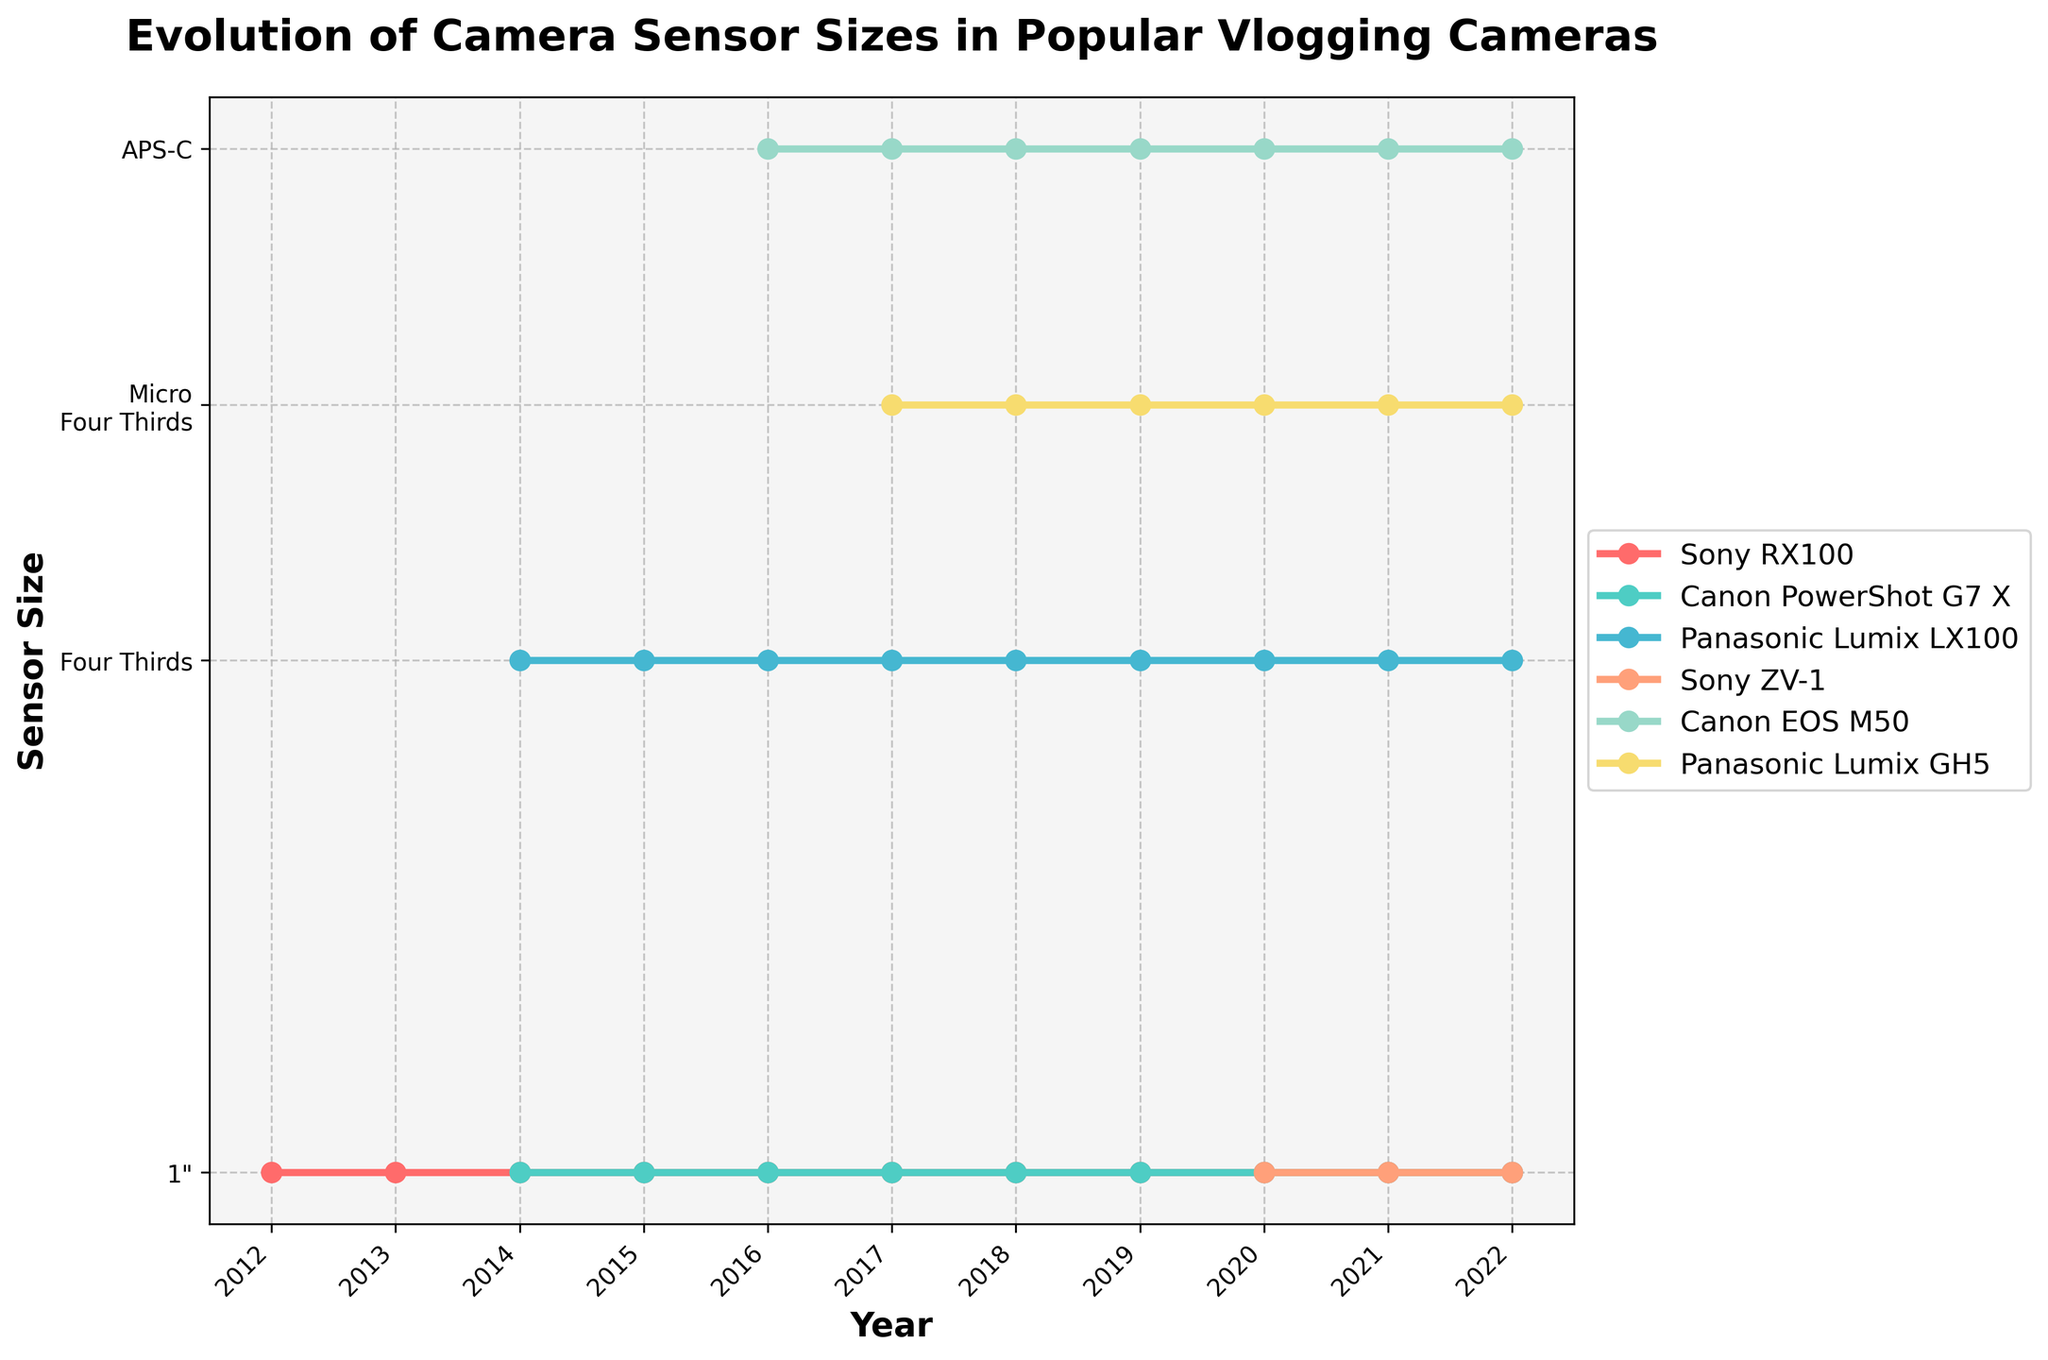Which camera introduced the '1"' sensor size first? By examining the plot, the earliest line labeled '1"' belongs to the Sony RX100 in 2012. Since this line starts from 2012, it's clear that the Sony RX100 was the first camera to introduce '1"' sensor size.
Answer: Sony RX100 In which year did the Panasonic Lumix GH5 first appear on the chart with a sensor size? By checking the plot for the first appearance of the Panasonic Lumix GH5 line, it is in 2017 when its line starts, indicating the sensor size was first noted that year.
Answer: 2017 How did the sensor size for Canon EOS M50 evolve from its introduction? The Canon EOS M50 line first appears in 2016 with a marker at APS-C, and it maintains this sensor size consistently through subsequent years up to 2022.
Answer: Stayed APS-C Compare the sensor sizes of Canon PowerShot G7 X and Panasonic Lumix LX100 in 2015. Which one has a larger sensor? According to the plot, in 2015, the Canon PowerShot G7 X has a sensor size of '1"', while the Panasonic Lumix LX100 has a 'Four Thirds' sensor size, where 'Four Thirds' is larger.
Answer: Panasonic Lumix LX100 Which camera brand has maintained the same sensor size throughout the decade? By observing the lines on the chart, the Sony RX100 has maintained a constant sensor size of '1"' from 2012 to 2022. Other cameras have had changes or were introduced later.
Answer: Sony RX100 In what year did the Sony ZV-1 first introduce, and what was its initial sensor size? By looking at the plot, the first appearance of the Sony ZV-1 line is in 2020 with a '1"' sensor size.
Answer: 2020, 1" On average, how many years does it take for a camera with '1"' sensor size to appear alongside new models? To find this, count the years when new camera models appeared with '1"' sensor sizes: Sony RX100 (2012), Canon PowerShot G7 X (2014), Sony ZV-1 (2020). Calculate the intervals, 2014-2012 = 2 years, 2020-2014 = 6 years, and find the average (2+6)/2 = 4 years.
Answer: 4 years Which camera models share the same sensor size in the year 2021? In 2021, the chart indicates that Sony RX100, Canon PowerShot G7 X, and Sony ZV-1 share the same sensor size of '1"'.
Answer: Sony RX100, Canon PowerShot G7 X, Sony ZV-1 What are the visual differences between the sensor sizes 'Four Thirds' and 'Micro Four Thirds'? Visually, 'Four Thirds' appears at a higher position on the vertical axis compared to 'Micro Four Thirds,' indicating it is larger. The chart uses different markers for these sizes and shows 'Four Thirds' closer to the APS-C line than 'Micro Four Thirds'.
Answer: 'Four Thirds' higher than 'Micro Four Thirds' What is the trend for Panasonic Lumix LX100 sensor size from its introduction year until 2022? From its introduction in 2014, the Panasonic Lumix LX100 maintains a consistent 'Four Thirds' sensor size through 2022.
Answer: Constant 'Four Thirds' 